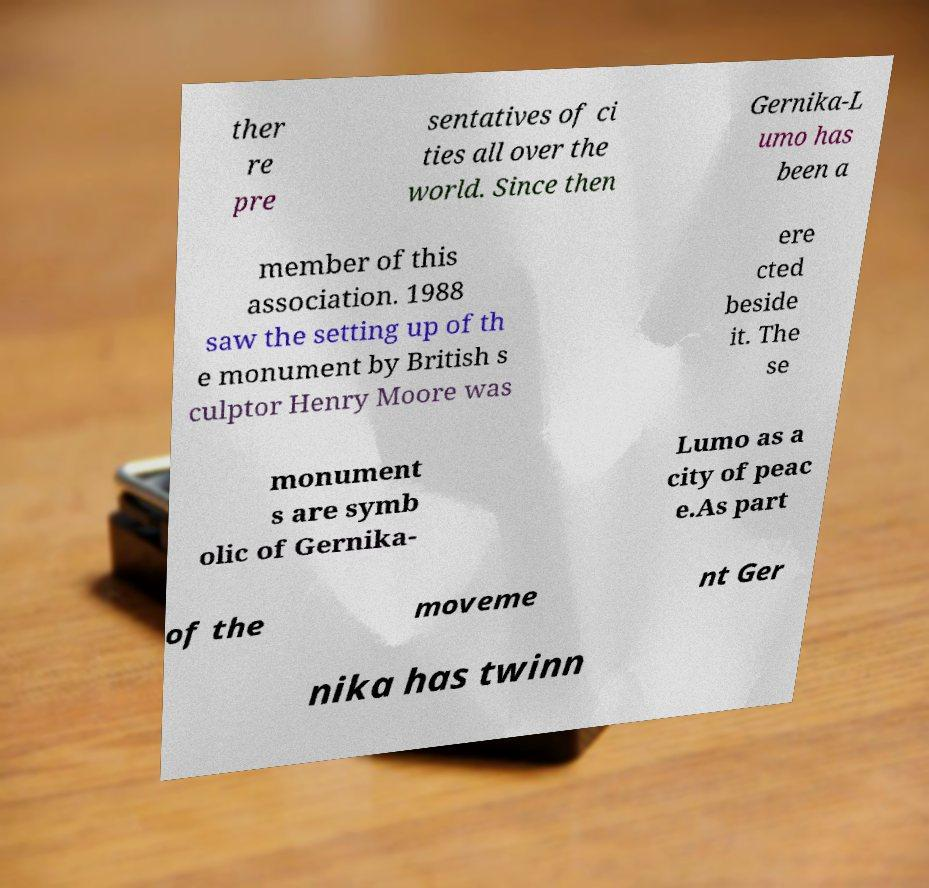I need the written content from this picture converted into text. Can you do that? ther re pre sentatives of ci ties all over the world. Since then Gernika-L umo has been a member of this association. 1988 saw the setting up of th e monument by British s culptor Henry Moore was ere cted beside it. The se monument s are symb olic of Gernika- Lumo as a city of peac e.As part of the moveme nt Ger nika has twinn 